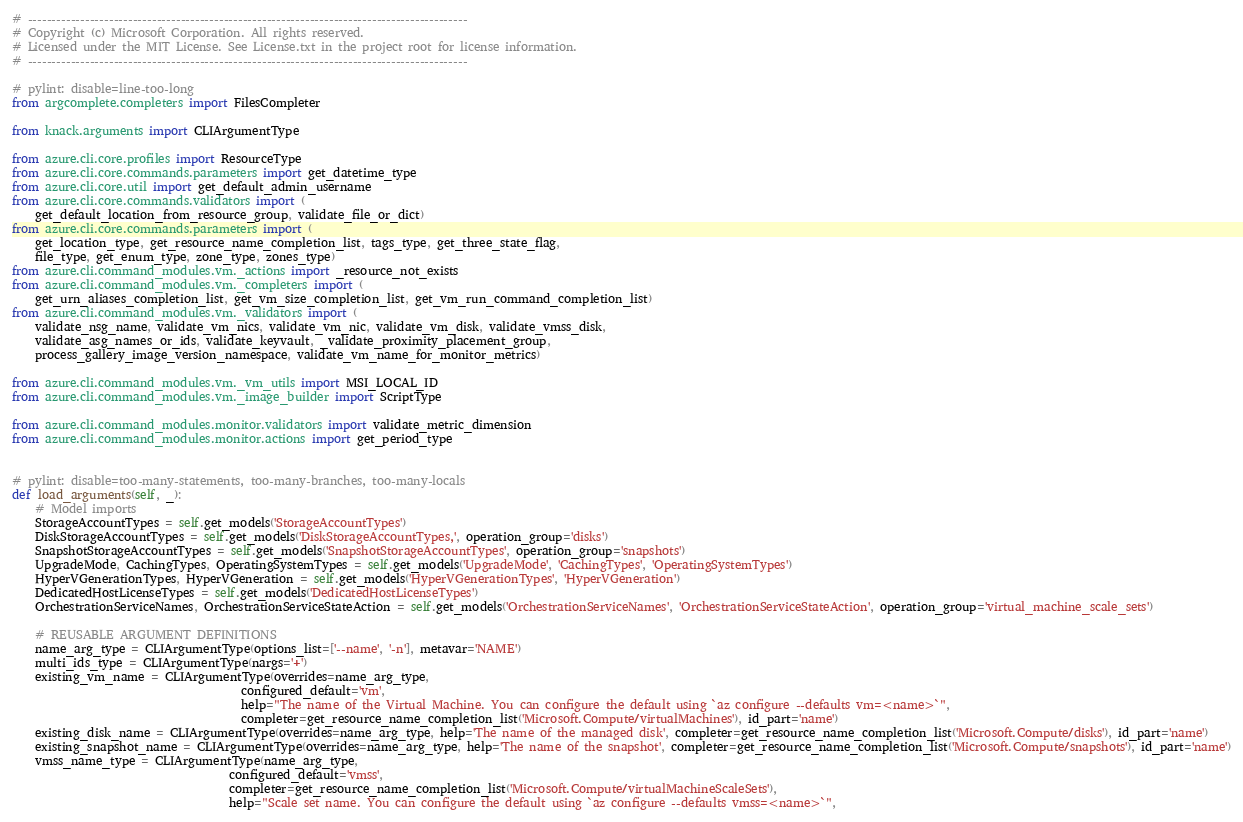Convert code to text. <code><loc_0><loc_0><loc_500><loc_500><_Python_># --------------------------------------------------------------------------------------------
# Copyright (c) Microsoft Corporation. All rights reserved.
# Licensed under the MIT License. See License.txt in the project root for license information.
# --------------------------------------------------------------------------------------------

# pylint: disable=line-too-long
from argcomplete.completers import FilesCompleter

from knack.arguments import CLIArgumentType

from azure.cli.core.profiles import ResourceType
from azure.cli.core.commands.parameters import get_datetime_type
from azure.cli.core.util import get_default_admin_username
from azure.cli.core.commands.validators import (
    get_default_location_from_resource_group, validate_file_or_dict)
from azure.cli.core.commands.parameters import (
    get_location_type, get_resource_name_completion_list, tags_type, get_three_state_flag,
    file_type, get_enum_type, zone_type, zones_type)
from azure.cli.command_modules.vm._actions import _resource_not_exists
from azure.cli.command_modules.vm._completers import (
    get_urn_aliases_completion_list, get_vm_size_completion_list, get_vm_run_command_completion_list)
from azure.cli.command_modules.vm._validators import (
    validate_nsg_name, validate_vm_nics, validate_vm_nic, validate_vm_disk, validate_vmss_disk,
    validate_asg_names_or_ids, validate_keyvault, _validate_proximity_placement_group,
    process_gallery_image_version_namespace, validate_vm_name_for_monitor_metrics)

from azure.cli.command_modules.vm._vm_utils import MSI_LOCAL_ID
from azure.cli.command_modules.vm._image_builder import ScriptType

from azure.cli.command_modules.monitor.validators import validate_metric_dimension
from azure.cli.command_modules.monitor.actions import get_period_type


# pylint: disable=too-many-statements, too-many-branches, too-many-locals
def load_arguments(self, _):
    # Model imports
    StorageAccountTypes = self.get_models('StorageAccountTypes')
    DiskStorageAccountTypes = self.get_models('DiskStorageAccountTypes,', operation_group='disks')
    SnapshotStorageAccountTypes = self.get_models('SnapshotStorageAccountTypes', operation_group='snapshots')
    UpgradeMode, CachingTypes, OperatingSystemTypes = self.get_models('UpgradeMode', 'CachingTypes', 'OperatingSystemTypes')
    HyperVGenerationTypes, HyperVGeneration = self.get_models('HyperVGenerationTypes', 'HyperVGeneration')
    DedicatedHostLicenseTypes = self.get_models('DedicatedHostLicenseTypes')
    OrchestrationServiceNames, OrchestrationServiceStateAction = self.get_models('OrchestrationServiceNames', 'OrchestrationServiceStateAction', operation_group='virtual_machine_scale_sets')

    # REUSABLE ARGUMENT DEFINITIONS
    name_arg_type = CLIArgumentType(options_list=['--name', '-n'], metavar='NAME')
    multi_ids_type = CLIArgumentType(nargs='+')
    existing_vm_name = CLIArgumentType(overrides=name_arg_type,
                                       configured_default='vm',
                                       help="The name of the Virtual Machine. You can configure the default using `az configure --defaults vm=<name>`",
                                       completer=get_resource_name_completion_list('Microsoft.Compute/virtualMachines'), id_part='name')
    existing_disk_name = CLIArgumentType(overrides=name_arg_type, help='The name of the managed disk', completer=get_resource_name_completion_list('Microsoft.Compute/disks'), id_part='name')
    existing_snapshot_name = CLIArgumentType(overrides=name_arg_type, help='The name of the snapshot', completer=get_resource_name_completion_list('Microsoft.Compute/snapshots'), id_part='name')
    vmss_name_type = CLIArgumentType(name_arg_type,
                                     configured_default='vmss',
                                     completer=get_resource_name_completion_list('Microsoft.Compute/virtualMachineScaleSets'),
                                     help="Scale set name. You can configure the default using `az configure --defaults vmss=<name>`",</code> 